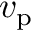Convert formula to latex. <formula><loc_0><loc_0><loc_500><loc_500>v _ { p }</formula> 